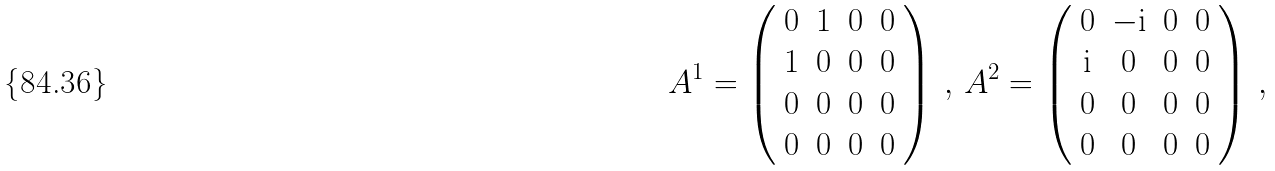<formula> <loc_0><loc_0><loc_500><loc_500>& A ^ { 1 } = \left ( \begin{array} { c c c c } 0 & 1 & 0 & 0 \\ 1 & 0 & 0 & 0 \\ 0 & 0 & 0 & 0 \\ 0 & 0 & 0 & 0 \end{array} \right ) \, , \, A ^ { 2 } = \left ( \begin{array} { c c c c } 0 & - \text {i} & 0 & 0 \\ \text {i} & 0 & 0 & 0 \\ 0 & 0 & 0 & 0 \\ 0 & 0 & 0 & 0 \end{array} \right ) \, ,</formula> 